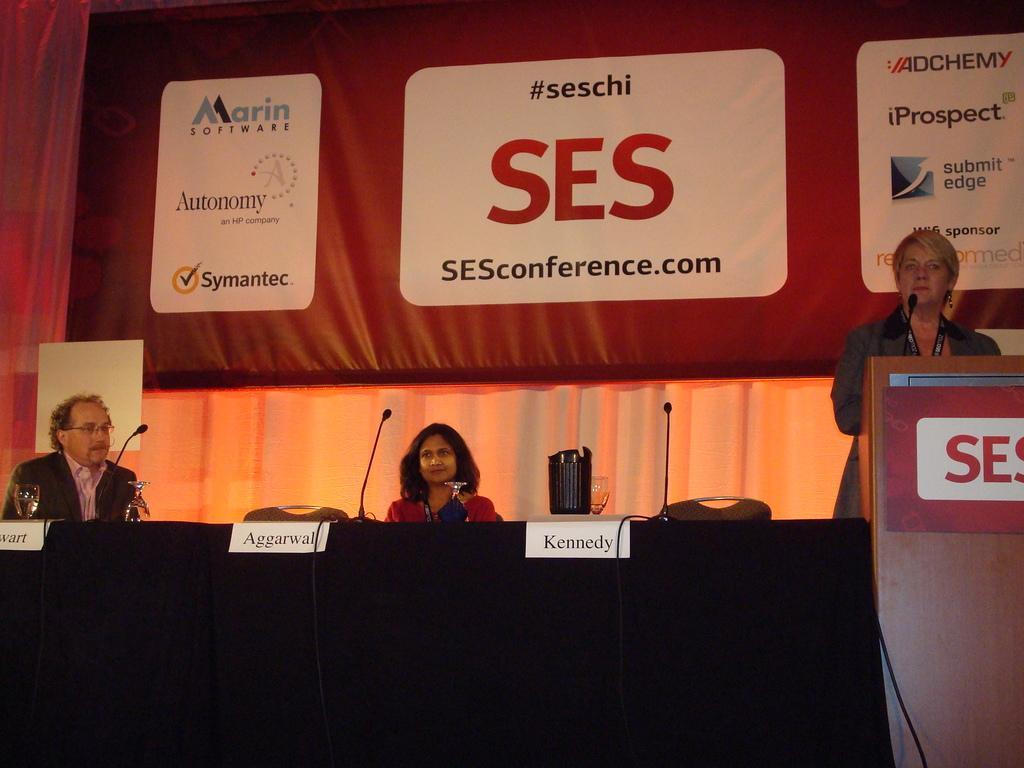Please provide a concise description of this image. In this image we can see a woman standing in front of a wooden podium and she is speaking on a microphone. Here we can see two persons sitting on the chairs. Here we can see a man on the left side is wearing a suit. Here we can see the table which is covered with black cloth. Here we can see the name plate boards, microphones and glasses are kept on the table. Here we can see the curtain on the left side. 